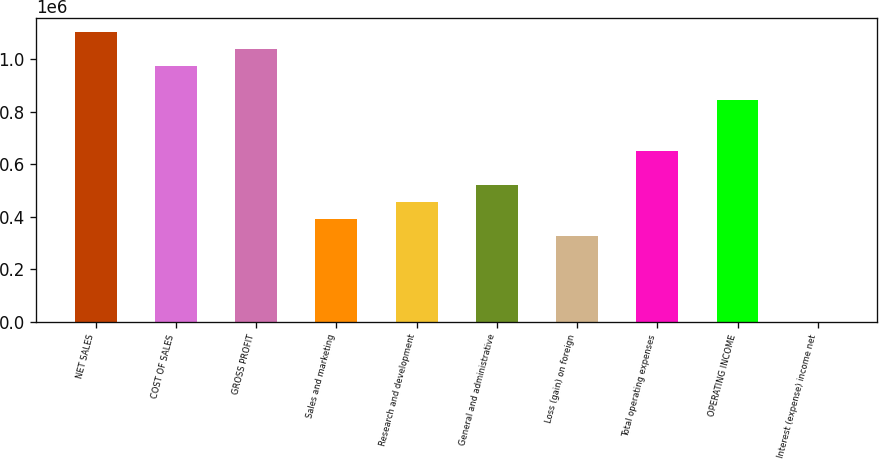Convert chart. <chart><loc_0><loc_0><loc_500><loc_500><bar_chart><fcel>NET SALES<fcel>COST OF SALES<fcel>GROSS PROFIT<fcel>Sales and marketing<fcel>Research and development<fcel>General and administrative<fcel>Loss (gain) on foreign<fcel>Total operating expenses<fcel>OPERATING INCOME<fcel>Interest (expense) income net<nl><fcel>1.10166e+06<fcel>972050<fcel>1.03685e+06<fcel>388821<fcel>453624<fcel>518427<fcel>324018<fcel>648034<fcel>842444<fcel>1<nl></chart> 